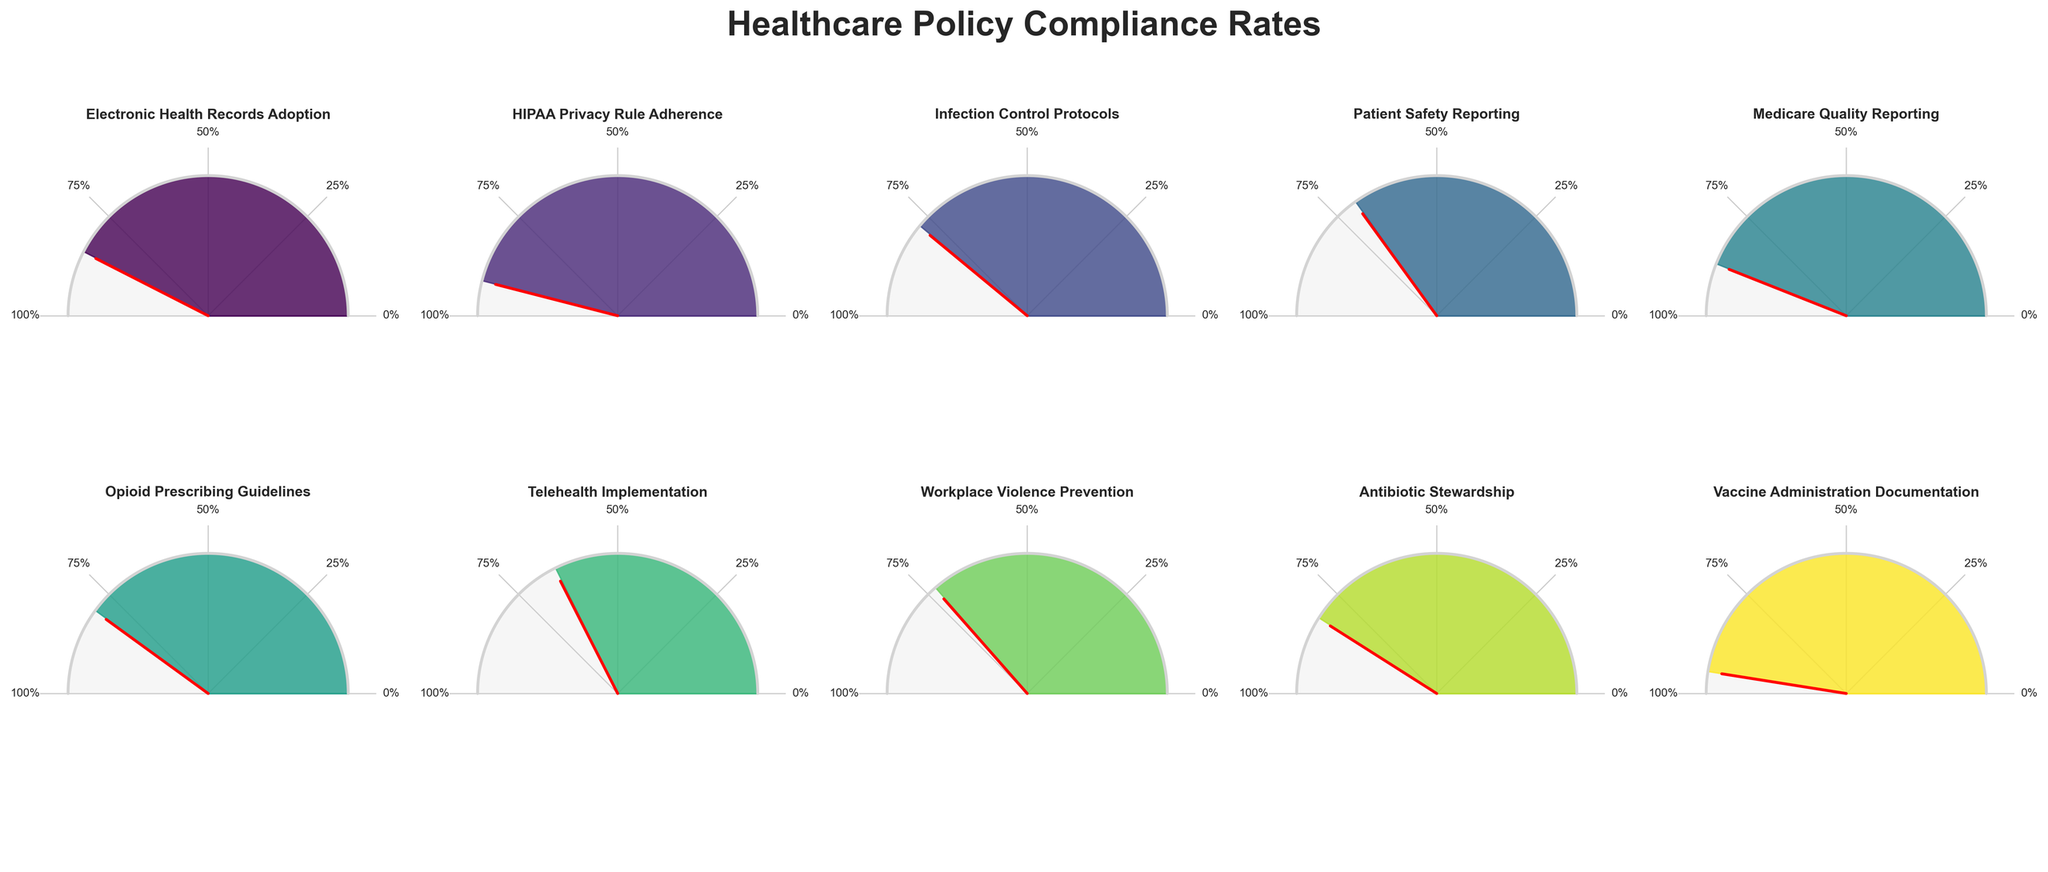What's the compliance rate with the HIPAA Privacy Rule Adherence? The title of the gauge chart for HIPAA Privacy Rule Adherence shows the compliance rate in percentage. By looking at this gauge chart, it can be directly read.
Answer: 92% Which policy has the lowest compliance rate? To find the policy with the lowest compliance rate, we need to look for the smallest value among the gauge charts. The smallest compliance rate value is 65% for Telehealth Implementation.
Answer: Telehealth Implementation What is the average compliance rate for the Medicare Quality Reporting, Opioid Prescribing Guidelines, and Antibiotic Stewardship? First, sum the compliance rates for the three policies: 88% (Medicare Quality Reporting) + 80% (Opioid Prescribing Guidelines) + 82% (Antibiotic Stewardship) = 250%. Then, divide by the number of policies: 250% / 3 = 83.33%.
Answer: 83.33% How many policies have compliance rates greater than 80%? Identify and count the policies with compliance rates above 80%. The policies are: Electronic Health Records Adoption (85%), HIPAA Privacy Rule Adherence (92%), Medicare Quality Reporting (88%), Antibiotic Stewardship (82%), and Vaccine Administration Documentation (95%). There are 5 such policies.
Answer: 5 Which compliance rate is closer to the median of all values? List all compliance rates: 65%, 70%, 73%, 78%, 80%, 82%, 85%, 88%, 92%, 95%. The median compliance rate (middle value in an ordered list) is 81% (average of 80% and 82%). The closest compliance rate is 80% for Opioid Prescribing Guidelines.
Answer: Opioid Prescribing Guidelines How much higher is the compliance rate for Electronic Health Records Adoption compared to Telehealth Implementation? Subtract the compliance rate of Telehealth Implementation from Electronic Health Records Adoption: 85% - 65% = 20%.
Answer: 20% What percentage of policies have compliance rates below 75%? Count the number of policies with compliance rates below 75%. The policies are: Telehealth Implementation (65%), Patient Safety Reporting (70%), and Workplace Violence Prevention (73%). There are 3 such policies out of 10, which is (3/10) = 30%.
Answer: 30% Which policies have compliance rates between 70% and 80%? Identify policies with compliance rates within the range 70% to 80%. The policies are: Patient Safety Reporting (70%), Infection Control Protocols (78%), Opioid Prescribing Guidelines (80%), and Workplace Violence Prevention (73%).
Answer: Patient Safety Reporting, Infection Control Protocols, Opioid Prescribing Guidelines, Workplace Violence Prevention What is the difference between the highest and lowest compliance rates? Subtract the lowest compliance rate (65% for Telehealth Implementation) from the highest compliance rate (95% for Vaccine Administration Documentation): 95% - 65% = 30%.
Answer: 30% Which compliance rate is exactly at the midpoint between the highest (Vaccine Administration Documentation) and lowest (Telehealth Implementation) rates? Calculate the midpoint between the highest and lowest compliance rates: (95% + 65%) / 2 = 80%. The policy with this compliance rate is Opioid Prescribing Guidelines.
Answer: Opioid Prescribing Guidelines 